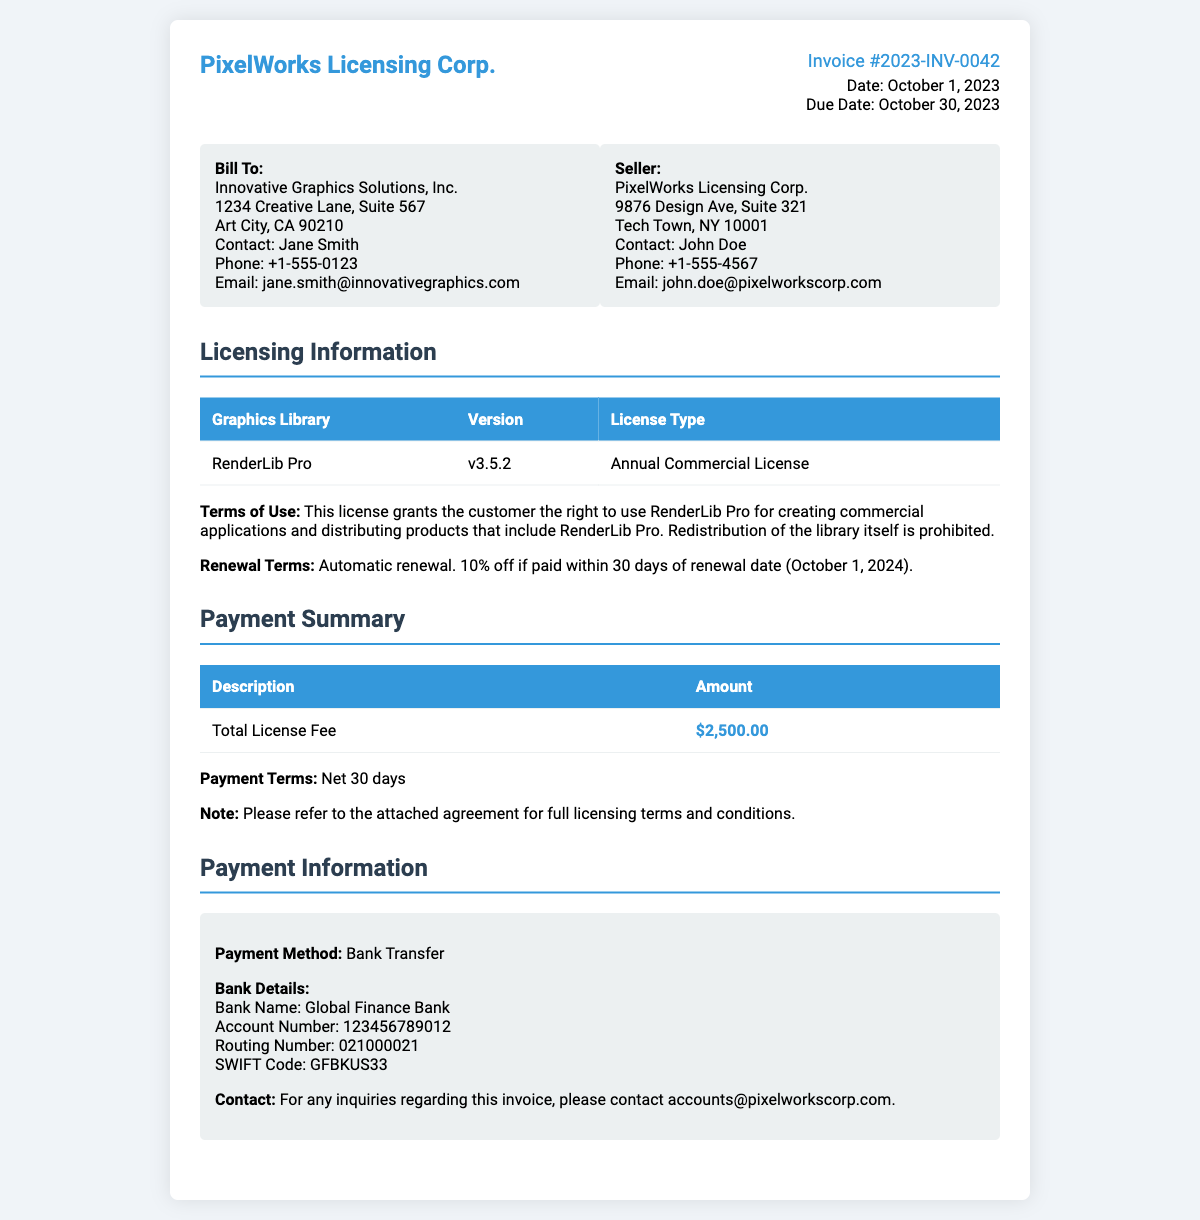What is the invoice number? The invoice number is detailed at the top of the document within the invoice details section.
Answer: Invoice #2023-INV-0042 What is the total license fee? The total license fee is listed in the payment summary section of the document.
Answer: $2,500.00 Who is the contact person for the bill to? The contact person for the bill to is found in the address section under the "Bill To" information.
Answer: Jane Smith What is the renewal date for the license? The renewal date for the license is specified under the licensing information section.
Answer: October 1, 2024 What type of license is being issued? The type of license is mentioned in the licensing information table.
Answer: Annual Commercial License What payment method is specified in the document? The payment method is clearly stated in the payment information section.
Answer: Bank Transfer What is the due date of the invoice? The due date is listed with the invoice details at the top of the document.
Answer: October 30, 2023 What discount is offered if paid within 30 days of renewal? The discount information is included in the renewal terms section of the document.
Answer: 10% off What is the SWIFT code for the bank? The SWIFT code is included in the payment information section under bank details.
Answer: GFBKUS33 